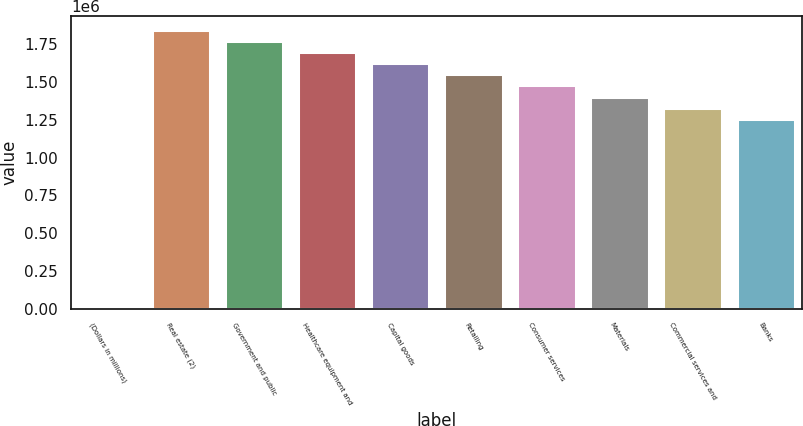Convert chart to OTSL. <chart><loc_0><loc_0><loc_500><loc_500><bar_chart><fcel>(Dollars in millions)<fcel>Real estate (2)<fcel>Government and public<fcel>Healthcare equipment and<fcel>Capital goods<fcel>Retailing<fcel>Consumer services<fcel>Materials<fcel>Commercial services and<fcel>Banks<nl><fcel>2010<fcel>1.84722e+06<fcel>1.77341e+06<fcel>1.69961e+06<fcel>1.6258e+06<fcel>1.55199e+06<fcel>1.47818e+06<fcel>1.40437e+06<fcel>1.33056e+06<fcel>1.25675e+06<nl></chart> 